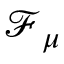Convert formula to latex. <formula><loc_0><loc_0><loc_500><loc_500>\mathcal { F } _ { \mu }</formula> 